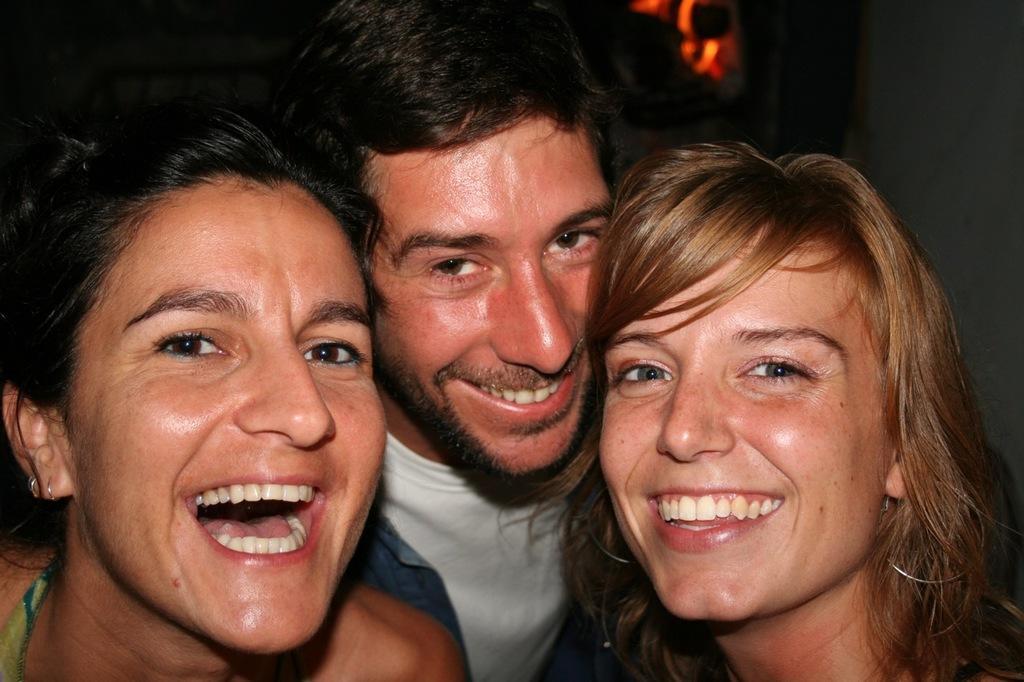Please provide a concise description of this image. There are people laughing in the foreground area of the image. 